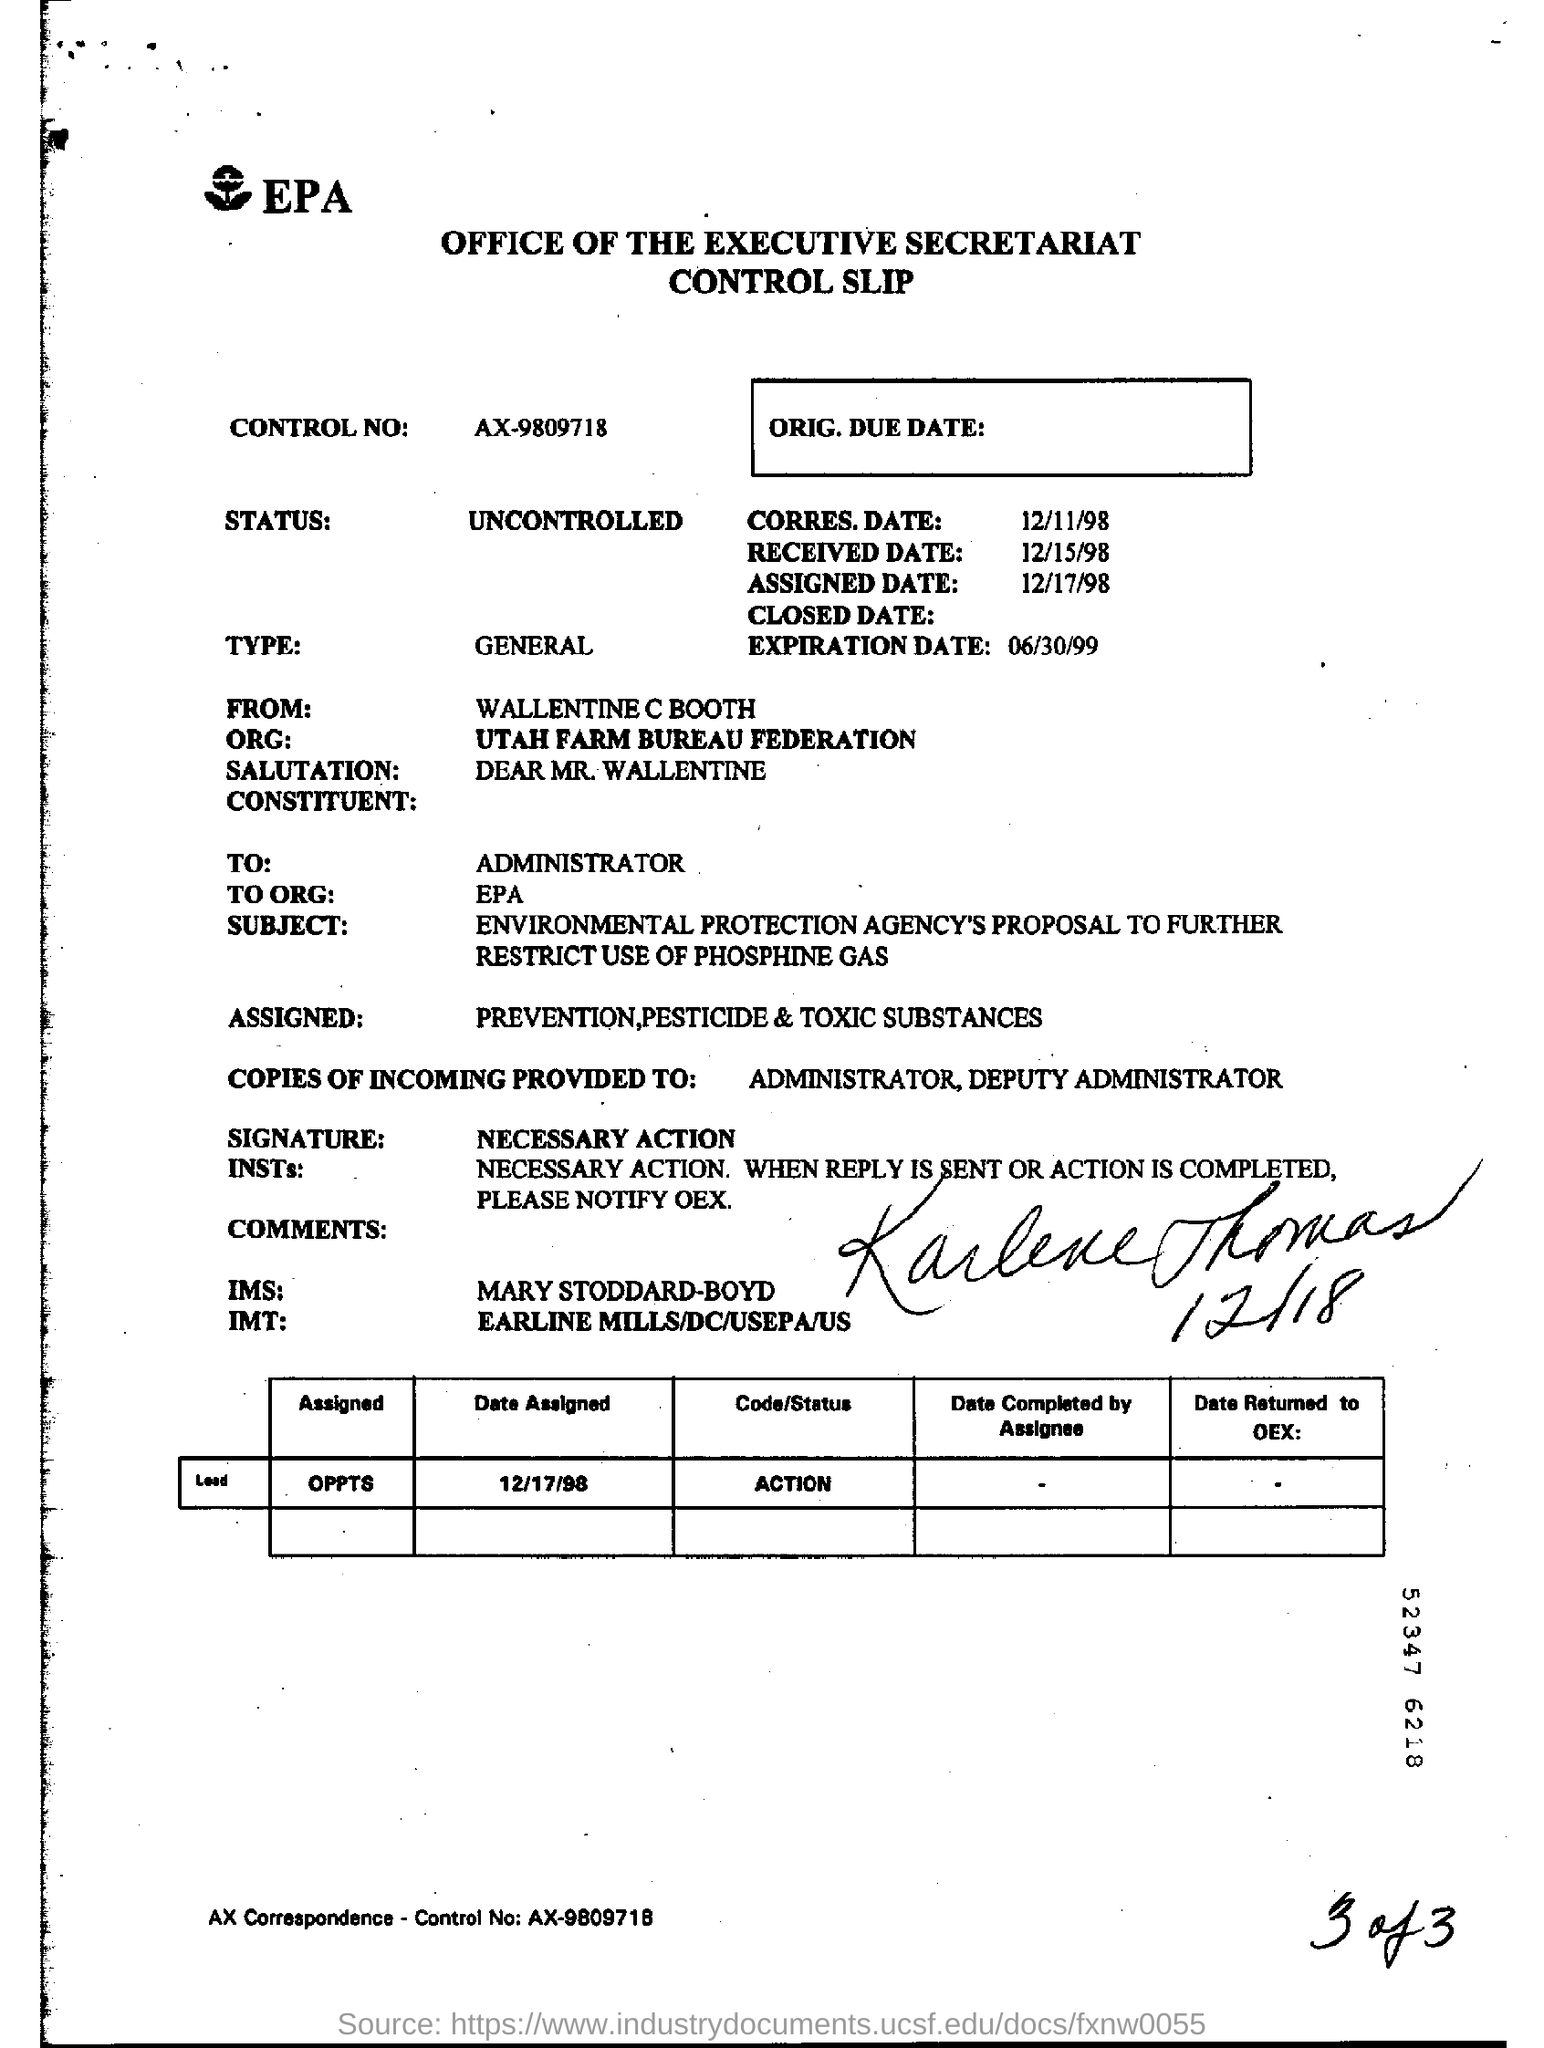Can you explain more about the content of this document? This document appears to be an EPA (Environmental Protection Agency) control slip. It's associated with a proposal regarding the use of phosphine gas and contains details about when the document was received, assigned, and the due dates. It includes communication from the Utah Farm Bureau Federation addressed to the EPA Administrator, which suggests a matter of regulatory concern related to environmental protection. What is the importance of phosphine gas in environmental protection? Phosphine gas is commonly used as a pesticide, particularly for fumigating stored grain and other agricultural products. It's highly toxic and has significant implications for environmental safety and human health. Discussions in documents like these likely pertain to regulations intended to protect the environment and human populations from its harmful effects by controlling its usage. 